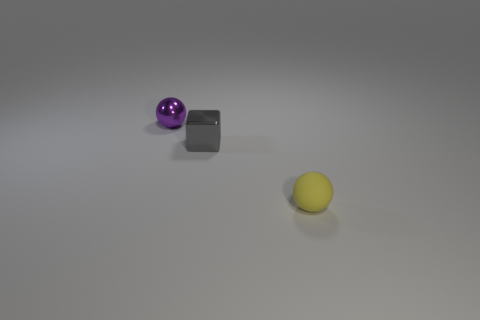The tiny shiny object that is the same shape as the tiny yellow rubber object is what color?
Give a very brief answer. Purple. Do the purple sphere and the gray metallic block have the same size?
Keep it short and to the point. Yes. What number of objects are tiny purple rubber objects or tiny objects that are in front of the tiny gray cube?
Make the answer very short. 1. What color is the ball that is on the left side of the metal thing in front of the small purple metallic sphere?
Ensure brevity in your answer.  Purple. Do the tiny metallic object in front of the small purple object and the small rubber object have the same color?
Your answer should be compact. No. There is a small sphere that is in front of the small gray thing; what is it made of?
Your response must be concise. Rubber. How big is the gray block?
Provide a short and direct response. Small. Is the material of the sphere right of the small purple ball the same as the small purple ball?
Your answer should be very brief. No. What number of tiny objects are there?
Provide a short and direct response. 3. How many things are either small blocks or small yellow objects?
Your answer should be very brief. 2. 